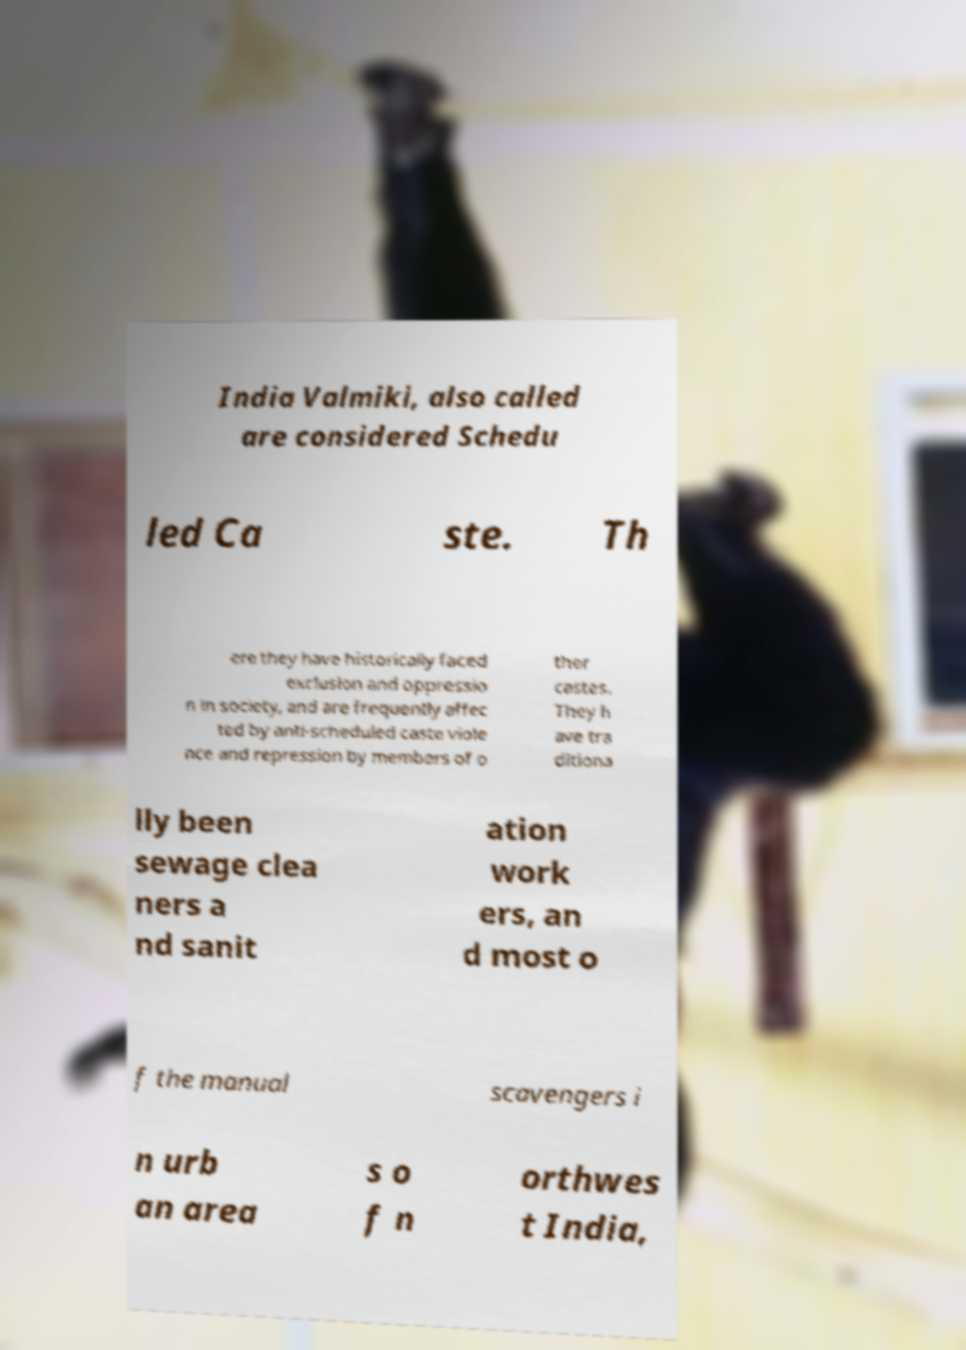Can you accurately transcribe the text from the provided image for me? India Valmiki, also called are considered Schedu led Ca ste. Th ere they have historically faced exclusion and oppressio n in society, and are frequently affec ted by anti-scheduled caste viole nce and repression by members of o ther castes. They h ave tra ditiona lly been sewage clea ners a nd sanit ation work ers, an d most o f the manual scavengers i n urb an area s o f n orthwes t India, 